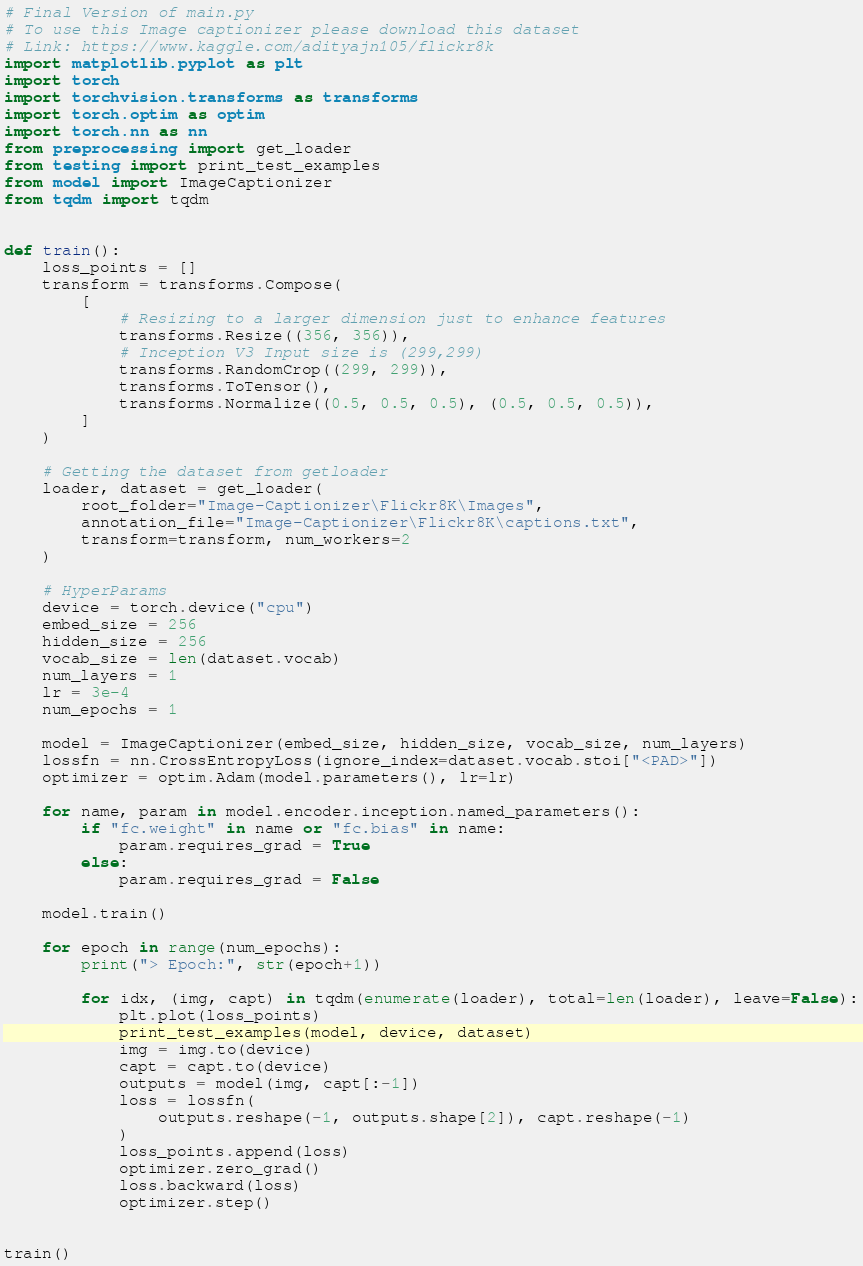<code> <loc_0><loc_0><loc_500><loc_500><_Python_># Final Version of main.py
# To use this Image captionizer please download this dataset
# Link: https://www.kaggle.com/adityajn105/flickr8k
import matplotlib.pyplot as plt
import torch
import torchvision.transforms as transforms
import torch.optim as optim
import torch.nn as nn
from preprocessing import get_loader
from testing import print_test_examples
from model import ImageCaptionizer
from tqdm import tqdm


def train():
    loss_points = []
    transform = transforms.Compose(
        [
            # Resizing to a larger dimension just to enhance features
            transforms.Resize((356, 356)),
            # Inception V3 Input size is (299,299)
            transforms.RandomCrop((299, 299)),
            transforms.ToTensor(),
            transforms.Normalize((0.5, 0.5, 0.5), (0.5, 0.5, 0.5)),
        ]
    )

    # Getting the dataset from getloader
    loader, dataset = get_loader(
        root_folder="Image-Captionizer\Flickr8K\Images",
        annotation_file="Image-Captionizer\Flickr8K\captions.txt",
        transform=transform, num_workers=2
    )

    # HyperParams
    device = torch.device("cpu")
    embed_size = 256
    hidden_size = 256
    vocab_size = len(dataset.vocab)
    num_layers = 1
    lr = 3e-4
    num_epochs = 1

    model = ImageCaptionizer(embed_size, hidden_size, vocab_size, num_layers)
    lossfn = nn.CrossEntropyLoss(ignore_index=dataset.vocab.stoi["<PAD>"])
    optimizer = optim.Adam(model.parameters(), lr=lr)

    for name, param in model.encoder.inception.named_parameters():
        if "fc.weight" in name or "fc.bias" in name:
            param.requires_grad = True
        else:
            param.requires_grad = False

    model.train()

    for epoch in range(num_epochs):
        print("> Epoch:", str(epoch+1))

        for idx, (img, capt) in tqdm(enumerate(loader), total=len(loader), leave=False):
            plt.plot(loss_points)
            print_test_examples(model, device, dataset)
            img = img.to(device)
            capt = capt.to(device)
            outputs = model(img, capt[:-1])
            loss = lossfn(
                outputs.reshape(-1, outputs.shape[2]), capt.reshape(-1)
            )
            loss_points.append(loss)
            optimizer.zero_grad()
            loss.backward(loss)
            optimizer.step()


train()
</code> 